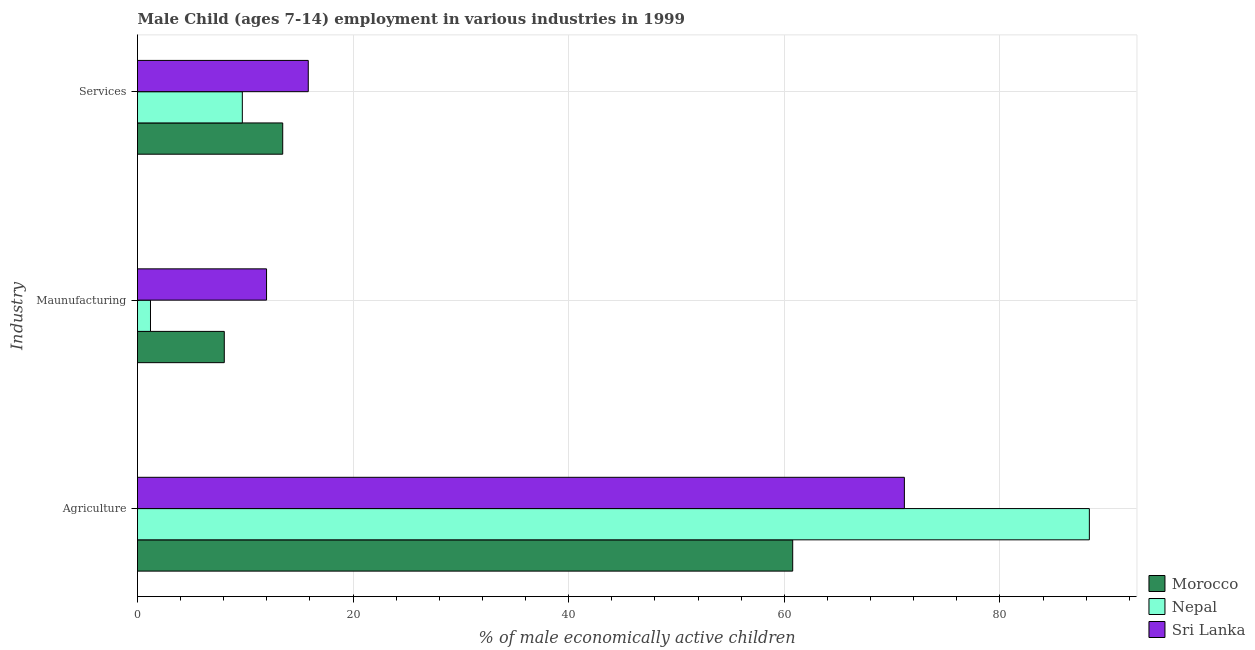How many groups of bars are there?
Provide a short and direct response. 3. Are the number of bars per tick equal to the number of legend labels?
Provide a succinct answer. Yes. Are the number of bars on each tick of the Y-axis equal?
Your response must be concise. Yes. How many bars are there on the 3rd tick from the top?
Make the answer very short. 3. What is the label of the 2nd group of bars from the top?
Keep it short and to the point. Maunufacturing. What is the percentage of economically active children in services in Nepal?
Provide a short and direct response. 9.72. Across all countries, what is the maximum percentage of economically active children in manufacturing?
Provide a succinct answer. 11.97. Across all countries, what is the minimum percentage of economically active children in manufacturing?
Ensure brevity in your answer.  1.2. In which country was the percentage of economically active children in agriculture maximum?
Your answer should be very brief. Nepal. In which country was the percentage of economically active children in manufacturing minimum?
Your response must be concise. Nepal. What is the total percentage of economically active children in services in the graph?
Your answer should be very brief. 39.03. What is the difference between the percentage of economically active children in services in Nepal and that in Morocco?
Your answer should be compact. -3.75. What is the difference between the percentage of economically active children in manufacturing in Morocco and the percentage of economically active children in services in Nepal?
Make the answer very short. -1.67. What is the average percentage of economically active children in services per country?
Give a very brief answer. 13.01. What is the difference between the percentage of economically active children in manufacturing and percentage of economically active children in services in Morocco?
Provide a succinct answer. -5.42. What is the ratio of the percentage of economically active children in manufacturing in Nepal to that in Morocco?
Your response must be concise. 0.15. What is the difference between the highest and the second highest percentage of economically active children in agriculture?
Ensure brevity in your answer.  17.16. What is the difference between the highest and the lowest percentage of economically active children in manufacturing?
Ensure brevity in your answer.  10.77. What does the 1st bar from the top in Maunufacturing represents?
Provide a short and direct response. Sri Lanka. What does the 2nd bar from the bottom in Services represents?
Your answer should be compact. Nepal. Are all the bars in the graph horizontal?
Offer a very short reply. Yes. How many countries are there in the graph?
Make the answer very short. 3. What is the difference between two consecutive major ticks on the X-axis?
Ensure brevity in your answer.  20. Are the values on the major ticks of X-axis written in scientific E-notation?
Keep it short and to the point. No. Does the graph contain any zero values?
Provide a short and direct response. No. Does the graph contain grids?
Your answer should be very brief. Yes. How many legend labels are there?
Your answer should be very brief. 3. How are the legend labels stacked?
Provide a succinct answer. Vertical. What is the title of the graph?
Ensure brevity in your answer.  Male Child (ages 7-14) employment in various industries in 1999. What is the label or title of the X-axis?
Your response must be concise. % of male economically active children. What is the label or title of the Y-axis?
Provide a short and direct response. Industry. What is the % of male economically active children in Morocco in Agriculture?
Give a very brief answer. 60.78. What is the % of male economically active children in Nepal in Agriculture?
Provide a succinct answer. 88.3. What is the % of male economically active children of Sri Lanka in Agriculture?
Your answer should be very brief. 71.14. What is the % of male economically active children of Morocco in Maunufacturing?
Keep it short and to the point. 8.05. What is the % of male economically active children in Nepal in Maunufacturing?
Offer a terse response. 1.2. What is the % of male economically active children of Sri Lanka in Maunufacturing?
Your response must be concise. 11.97. What is the % of male economically active children in Morocco in Services?
Keep it short and to the point. 13.47. What is the % of male economically active children of Nepal in Services?
Your response must be concise. 9.72. What is the % of male economically active children of Sri Lanka in Services?
Make the answer very short. 15.84. Across all Industry, what is the maximum % of male economically active children in Morocco?
Give a very brief answer. 60.78. Across all Industry, what is the maximum % of male economically active children of Nepal?
Make the answer very short. 88.3. Across all Industry, what is the maximum % of male economically active children in Sri Lanka?
Keep it short and to the point. 71.14. Across all Industry, what is the minimum % of male economically active children in Morocco?
Give a very brief answer. 8.05. Across all Industry, what is the minimum % of male economically active children in Nepal?
Offer a terse response. 1.2. Across all Industry, what is the minimum % of male economically active children of Sri Lanka?
Offer a very short reply. 11.97. What is the total % of male economically active children of Morocco in the graph?
Offer a very short reply. 82.3. What is the total % of male economically active children of Nepal in the graph?
Make the answer very short. 99.23. What is the total % of male economically active children in Sri Lanka in the graph?
Offer a very short reply. 98.95. What is the difference between the % of male economically active children of Morocco in Agriculture and that in Maunufacturing?
Offer a terse response. 52.73. What is the difference between the % of male economically active children of Nepal in Agriculture and that in Maunufacturing?
Your response must be concise. 87.1. What is the difference between the % of male economically active children of Sri Lanka in Agriculture and that in Maunufacturing?
Keep it short and to the point. 59.17. What is the difference between the % of male economically active children in Morocco in Agriculture and that in Services?
Provide a short and direct response. 47.31. What is the difference between the % of male economically active children in Nepal in Agriculture and that in Services?
Ensure brevity in your answer.  78.58. What is the difference between the % of male economically active children of Sri Lanka in Agriculture and that in Services?
Provide a succinct answer. 55.3. What is the difference between the % of male economically active children of Morocco in Maunufacturing and that in Services?
Offer a very short reply. -5.42. What is the difference between the % of male economically active children in Nepal in Maunufacturing and that in Services?
Your answer should be compact. -8.52. What is the difference between the % of male economically active children of Sri Lanka in Maunufacturing and that in Services?
Offer a very short reply. -3.87. What is the difference between the % of male economically active children of Morocco in Agriculture and the % of male economically active children of Nepal in Maunufacturing?
Make the answer very short. 59.58. What is the difference between the % of male economically active children of Morocco in Agriculture and the % of male economically active children of Sri Lanka in Maunufacturing?
Offer a very short reply. 48.81. What is the difference between the % of male economically active children in Nepal in Agriculture and the % of male economically active children in Sri Lanka in Maunufacturing?
Make the answer very short. 76.33. What is the difference between the % of male economically active children in Morocco in Agriculture and the % of male economically active children in Nepal in Services?
Your response must be concise. 51.06. What is the difference between the % of male economically active children in Morocco in Agriculture and the % of male economically active children in Sri Lanka in Services?
Provide a short and direct response. 44.94. What is the difference between the % of male economically active children in Nepal in Agriculture and the % of male economically active children in Sri Lanka in Services?
Make the answer very short. 72.46. What is the difference between the % of male economically active children of Morocco in Maunufacturing and the % of male economically active children of Nepal in Services?
Your response must be concise. -1.67. What is the difference between the % of male economically active children of Morocco in Maunufacturing and the % of male economically active children of Sri Lanka in Services?
Give a very brief answer. -7.79. What is the difference between the % of male economically active children of Nepal in Maunufacturing and the % of male economically active children of Sri Lanka in Services?
Provide a succinct answer. -14.64. What is the average % of male economically active children in Morocco per Industry?
Your answer should be very brief. 27.43. What is the average % of male economically active children in Nepal per Industry?
Give a very brief answer. 33.08. What is the average % of male economically active children in Sri Lanka per Industry?
Offer a terse response. 32.98. What is the difference between the % of male economically active children of Morocco and % of male economically active children of Nepal in Agriculture?
Ensure brevity in your answer.  -27.52. What is the difference between the % of male economically active children of Morocco and % of male economically active children of Sri Lanka in Agriculture?
Make the answer very short. -10.36. What is the difference between the % of male economically active children in Nepal and % of male economically active children in Sri Lanka in Agriculture?
Provide a short and direct response. 17.16. What is the difference between the % of male economically active children of Morocco and % of male economically active children of Nepal in Maunufacturing?
Your answer should be very brief. 6.85. What is the difference between the % of male economically active children of Morocco and % of male economically active children of Sri Lanka in Maunufacturing?
Provide a short and direct response. -3.92. What is the difference between the % of male economically active children in Nepal and % of male economically active children in Sri Lanka in Maunufacturing?
Your answer should be very brief. -10.77. What is the difference between the % of male economically active children of Morocco and % of male economically active children of Nepal in Services?
Your answer should be compact. 3.75. What is the difference between the % of male economically active children of Morocco and % of male economically active children of Sri Lanka in Services?
Offer a terse response. -2.37. What is the difference between the % of male economically active children of Nepal and % of male economically active children of Sri Lanka in Services?
Make the answer very short. -6.12. What is the ratio of the % of male economically active children of Morocco in Agriculture to that in Maunufacturing?
Ensure brevity in your answer.  7.55. What is the ratio of the % of male economically active children in Nepal in Agriculture to that in Maunufacturing?
Keep it short and to the point. 73.36. What is the ratio of the % of male economically active children in Sri Lanka in Agriculture to that in Maunufacturing?
Provide a succinct answer. 5.94. What is the ratio of the % of male economically active children in Morocco in Agriculture to that in Services?
Your response must be concise. 4.51. What is the ratio of the % of male economically active children in Nepal in Agriculture to that in Services?
Your answer should be compact. 9.08. What is the ratio of the % of male economically active children in Sri Lanka in Agriculture to that in Services?
Your answer should be very brief. 4.49. What is the ratio of the % of male economically active children of Morocco in Maunufacturing to that in Services?
Your response must be concise. 0.6. What is the ratio of the % of male economically active children in Nepal in Maunufacturing to that in Services?
Offer a very short reply. 0.12. What is the ratio of the % of male economically active children in Sri Lanka in Maunufacturing to that in Services?
Offer a terse response. 0.76. What is the difference between the highest and the second highest % of male economically active children of Morocco?
Your response must be concise. 47.31. What is the difference between the highest and the second highest % of male economically active children in Nepal?
Keep it short and to the point. 78.58. What is the difference between the highest and the second highest % of male economically active children of Sri Lanka?
Ensure brevity in your answer.  55.3. What is the difference between the highest and the lowest % of male economically active children of Morocco?
Give a very brief answer. 52.73. What is the difference between the highest and the lowest % of male economically active children of Nepal?
Your answer should be compact. 87.1. What is the difference between the highest and the lowest % of male economically active children of Sri Lanka?
Offer a terse response. 59.17. 